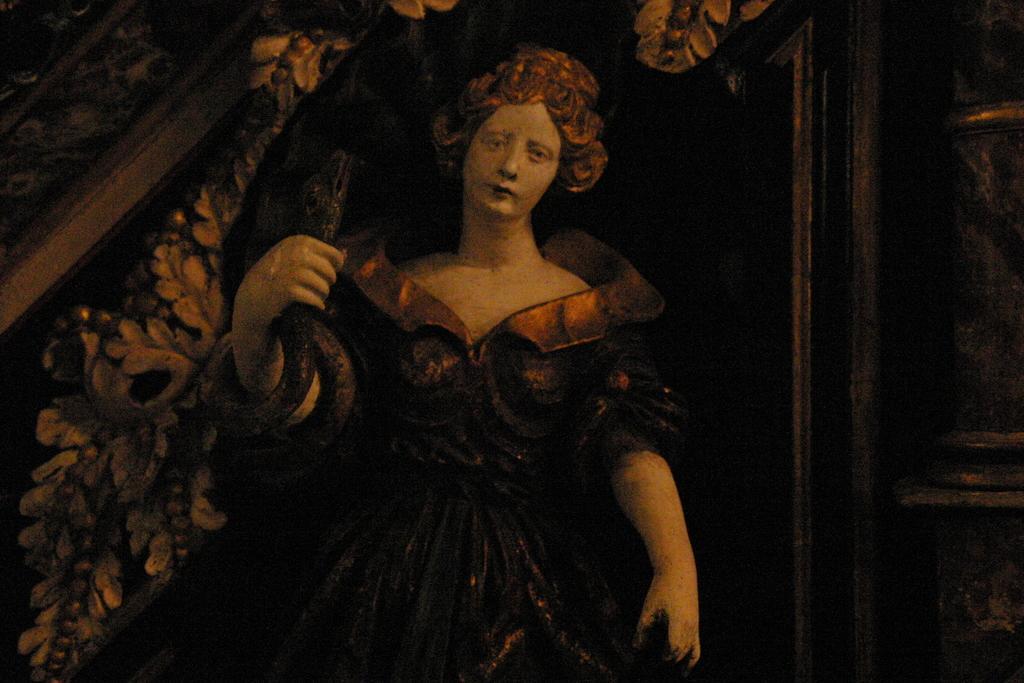Please provide a concise description of this image. In this picture we can see painting of a person. 